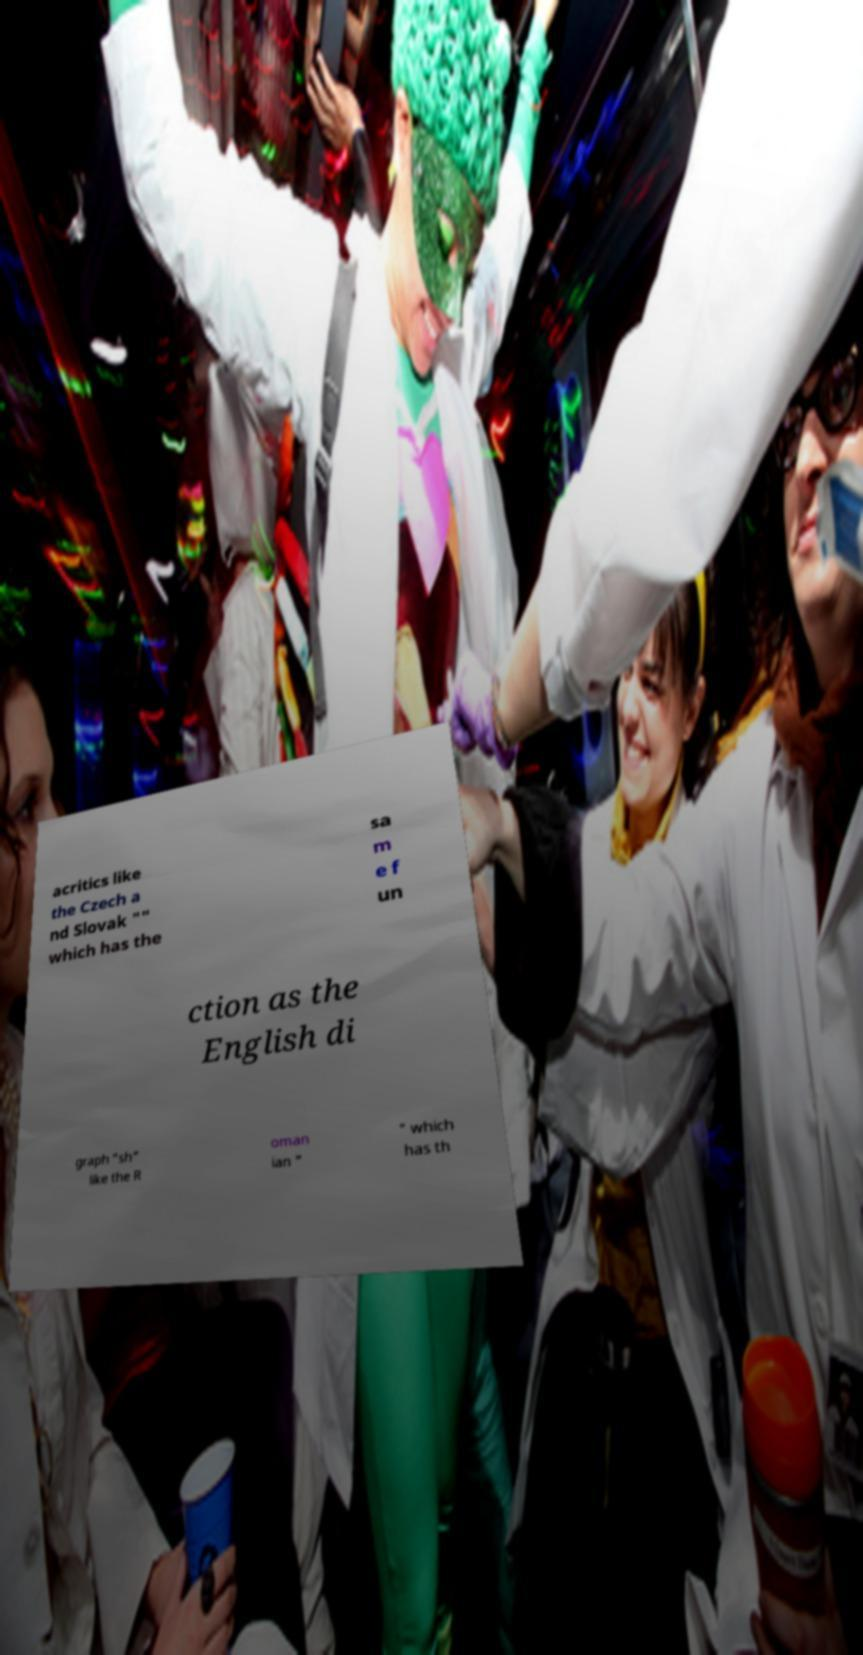For documentation purposes, I need the text within this image transcribed. Could you provide that? acritics like the Czech a nd Slovak "" which has the sa m e f un ction as the English di graph "sh" like the R oman ian " " which has th 